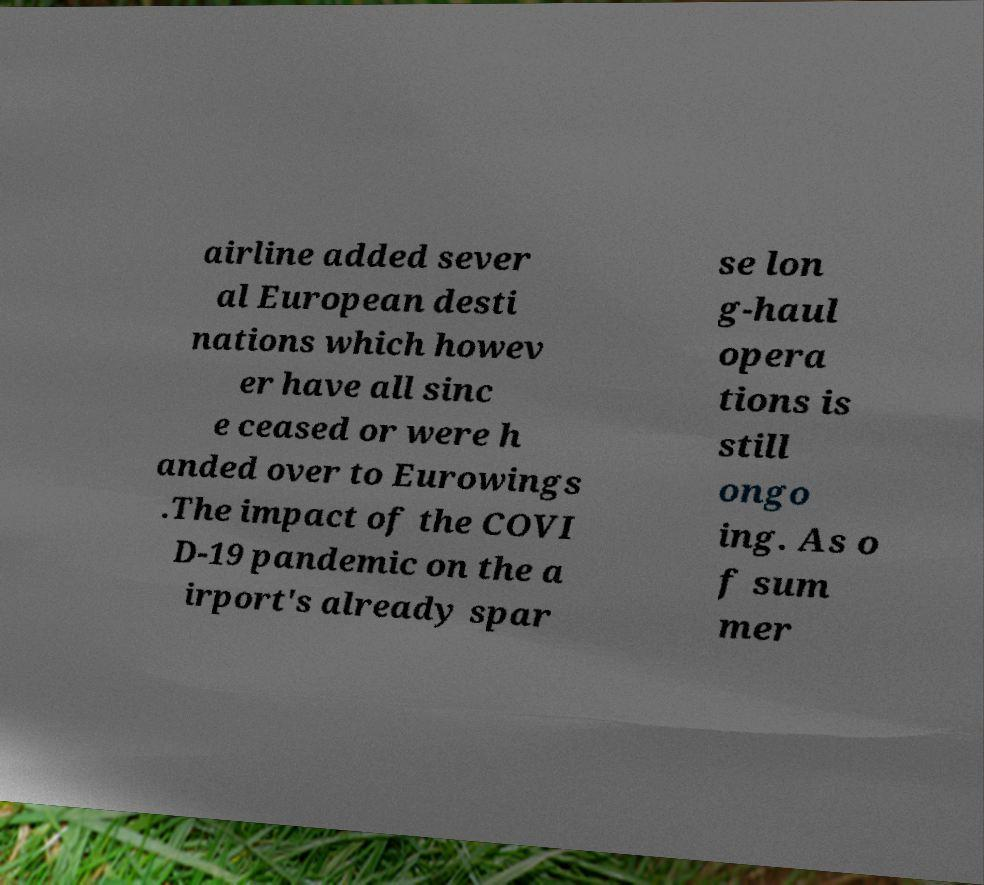Could you extract and type out the text from this image? airline added sever al European desti nations which howev er have all sinc e ceased or were h anded over to Eurowings .The impact of the COVI D-19 pandemic on the a irport's already spar se lon g-haul opera tions is still ongo ing. As o f sum mer 